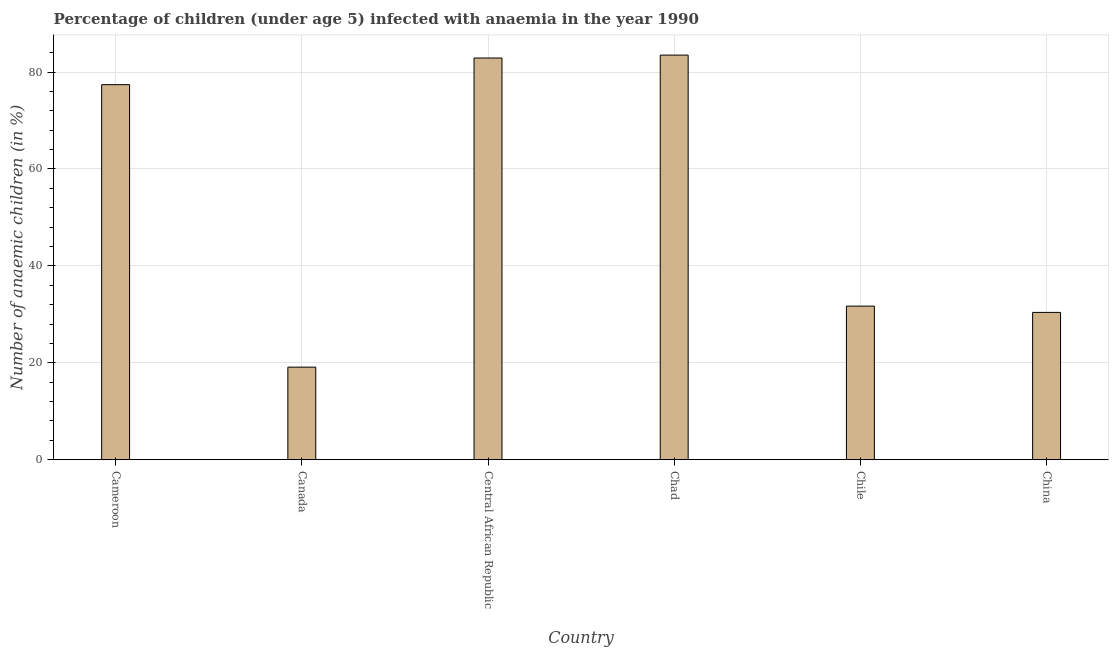Does the graph contain any zero values?
Offer a terse response. No. Does the graph contain grids?
Provide a short and direct response. Yes. What is the title of the graph?
Your answer should be very brief. Percentage of children (under age 5) infected with anaemia in the year 1990. What is the label or title of the Y-axis?
Give a very brief answer. Number of anaemic children (in %). What is the number of anaemic children in Canada?
Provide a short and direct response. 19.1. Across all countries, what is the maximum number of anaemic children?
Your response must be concise. 83.5. Across all countries, what is the minimum number of anaemic children?
Keep it short and to the point. 19.1. In which country was the number of anaemic children maximum?
Provide a succinct answer. Chad. What is the sum of the number of anaemic children?
Give a very brief answer. 325. What is the difference between the number of anaemic children in Cameroon and Chile?
Give a very brief answer. 45.7. What is the average number of anaemic children per country?
Provide a succinct answer. 54.17. What is the median number of anaemic children?
Make the answer very short. 54.55. What is the ratio of the number of anaemic children in Cameroon to that in Chile?
Your response must be concise. 2.44. Is the difference between the number of anaemic children in Cameroon and Canada greater than the difference between any two countries?
Make the answer very short. No. What is the difference between the highest and the second highest number of anaemic children?
Ensure brevity in your answer.  0.6. Is the sum of the number of anaemic children in Central African Republic and Chad greater than the maximum number of anaemic children across all countries?
Ensure brevity in your answer.  Yes. What is the difference between the highest and the lowest number of anaemic children?
Give a very brief answer. 64.4. How many bars are there?
Your answer should be compact. 6. What is the difference between two consecutive major ticks on the Y-axis?
Offer a terse response. 20. What is the Number of anaemic children (in %) of Cameroon?
Your answer should be compact. 77.4. What is the Number of anaemic children (in %) in Central African Republic?
Offer a terse response. 82.9. What is the Number of anaemic children (in %) of Chad?
Give a very brief answer. 83.5. What is the Number of anaemic children (in %) of Chile?
Ensure brevity in your answer.  31.7. What is the Number of anaemic children (in %) in China?
Your answer should be very brief. 30.4. What is the difference between the Number of anaemic children (in %) in Cameroon and Canada?
Provide a short and direct response. 58.3. What is the difference between the Number of anaemic children (in %) in Cameroon and Chad?
Offer a very short reply. -6.1. What is the difference between the Number of anaemic children (in %) in Cameroon and Chile?
Offer a terse response. 45.7. What is the difference between the Number of anaemic children (in %) in Canada and Central African Republic?
Your response must be concise. -63.8. What is the difference between the Number of anaemic children (in %) in Canada and Chad?
Give a very brief answer. -64.4. What is the difference between the Number of anaemic children (in %) in Canada and Chile?
Provide a succinct answer. -12.6. What is the difference between the Number of anaemic children (in %) in Canada and China?
Your answer should be very brief. -11.3. What is the difference between the Number of anaemic children (in %) in Central African Republic and Chad?
Ensure brevity in your answer.  -0.6. What is the difference between the Number of anaemic children (in %) in Central African Republic and Chile?
Keep it short and to the point. 51.2. What is the difference between the Number of anaemic children (in %) in Central African Republic and China?
Your answer should be very brief. 52.5. What is the difference between the Number of anaemic children (in %) in Chad and Chile?
Ensure brevity in your answer.  51.8. What is the difference between the Number of anaemic children (in %) in Chad and China?
Offer a terse response. 53.1. What is the ratio of the Number of anaemic children (in %) in Cameroon to that in Canada?
Your response must be concise. 4.05. What is the ratio of the Number of anaemic children (in %) in Cameroon to that in Central African Republic?
Offer a very short reply. 0.93. What is the ratio of the Number of anaemic children (in %) in Cameroon to that in Chad?
Offer a very short reply. 0.93. What is the ratio of the Number of anaemic children (in %) in Cameroon to that in Chile?
Ensure brevity in your answer.  2.44. What is the ratio of the Number of anaemic children (in %) in Cameroon to that in China?
Give a very brief answer. 2.55. What is the ratio of the Number of anaemic children (in %) in Canada to that in Central African Republic?
Offer a terse response. 0.23. What is the ratio of the Number of anaemic children (in %) in Canada to that in Chad?
Your answer should be compact. 0.23. What is the ratio of the Number of anaemic children (in %) in Canada to that in Chile?
Your response must be concise. 0.6. What is the ratio of the Number of anaemic children (in %) in Canada to that in China?
Make the answer very short. 0.63. What is the ratio of the Number of anaemic children (in %) in Central African Republic to that in Chile?
Your response must be concise. 2.62. What is the ratio of the Number of anaemic children (in %) in Central African Republic to that in China?
Offer a very short reply. 2.73. What is the ratio of the Number of anaemic children (in %) in Chad to that in Chile?
Your answer should be compact. 2.63. What is the ratio of the Number of anaemic children (in %) in Chad to that in China?
Your answer should be compact. 2.75. What is the ratio of the Number of anaemic children (in %) in Chile to that in China?
Provide a succinct answer. 1.04. 